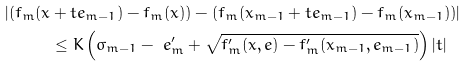<formula> <loc_0><loc_0><loc_500><loc_500>| ( f _ { m } ( x & + t e _ { m - 1 } ) - f _ { m } ( x ) ) - ( f _ { m } ( x _ { m - 1 } + t e _ { m - 1 } ) - f _ { m } ( x _ { m - 1 } ) ) | \\ & \leq K \left ( \sigma _ { m - 1 } - \ e _ { m } ^ { \prime } + \sqrt { f _ { m } ^ { \prime } ( x , e ) - f _ { m } ^ { \prime } ( x _ { m - 1 } , e _ { m - 1 } ) } \right ) | t |</formula> 